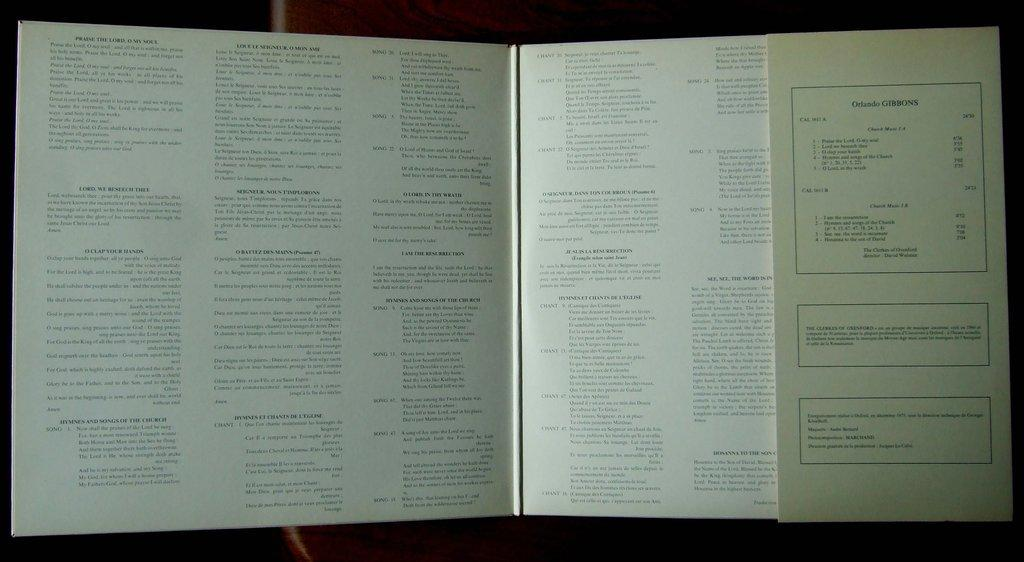<image>
Share a concise interpretation of the image provided. The dust cover of a book contains the name Orlando Gibbons. 